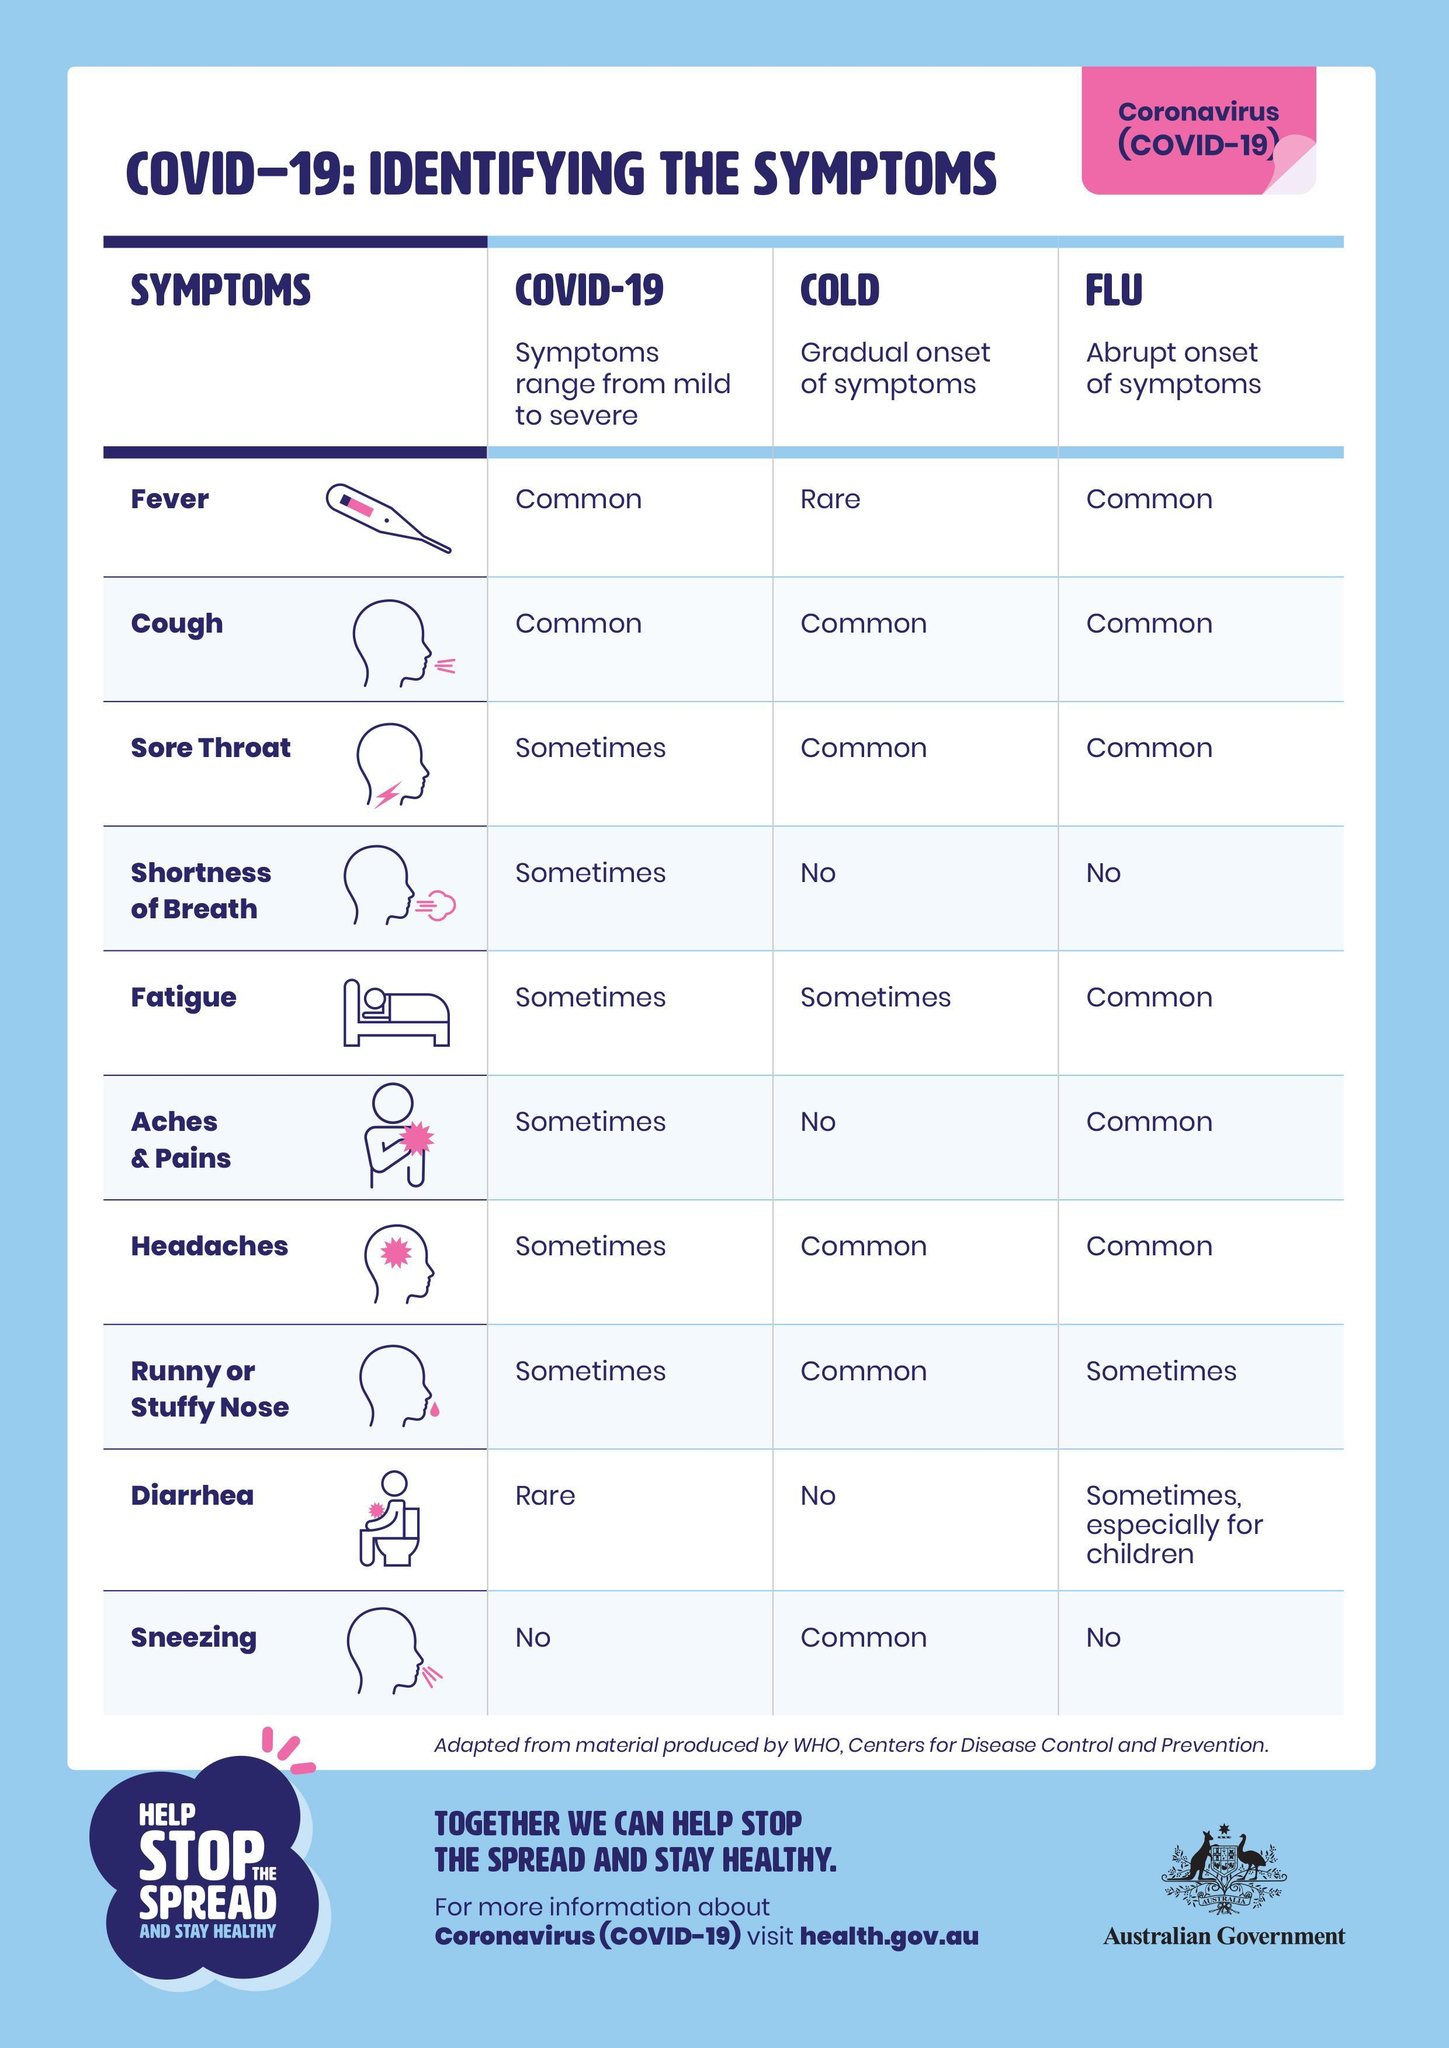Which symptom is common for Covid-19, Cold & Flu?
Answer the question with a short phrase. Cough Which is a considered as a very rare symptom of COVID-19? Diarrhea 